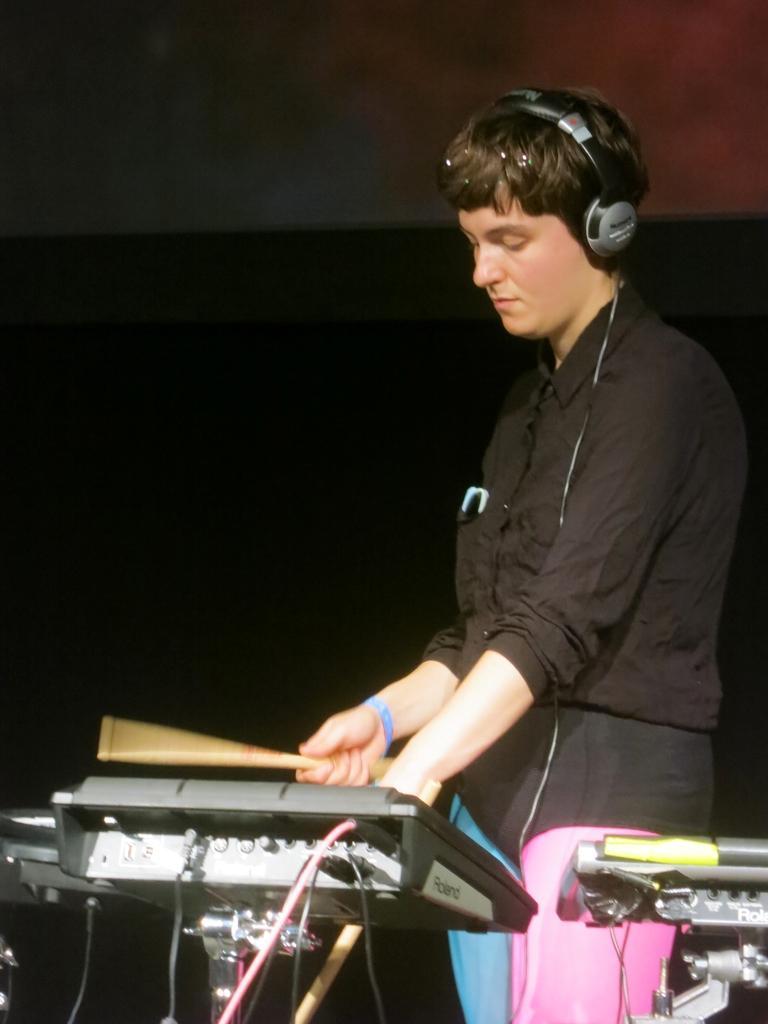In one or two sentences, can you explain what this image depicts? In this image I can see a person wearing a head phones and holding sticks and standing in front of musical instrument and musical instrument visible at the bottom and background is dark. 